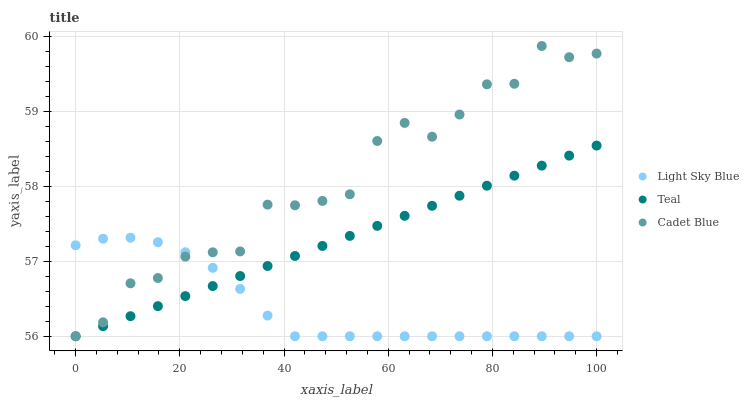Does Light Sky Blue have the minimum area under the curve?
Answer yes or no. Yes. Does Cadet Blue have the maximum area under the curve?
Answer yes or no. Yes. Does Teal have the minimum area under the curve?
Answer yes or no. No. Does Teal have the maximum area under the curve?
Answer yes or no. No. Is Teal the smoothest?
Answer yes or no. Yes. Is Cadet Blue the roughest?
Answer yes or no. Yes. Is Light Sky Blue the smoothest?
Answer yes or no. No. Is Light Sky Blue the roughest?
Answer yes or no. No. Does Cadet Blue have the lowest value?
Answer yes or no. Yes. Does Cadet Blue have the highest value?
Answer yes or no. Yes. Does Teal have the highest value?
Answer yes or no. No. Does Light Sky Blue intersect Teal?
Answer yes or no. Yes. Is Light Sky Blue less than Teal?
Answer yes or no. No. Is Light Sky Blue greater than Teal?
Answer yes or no. No. 